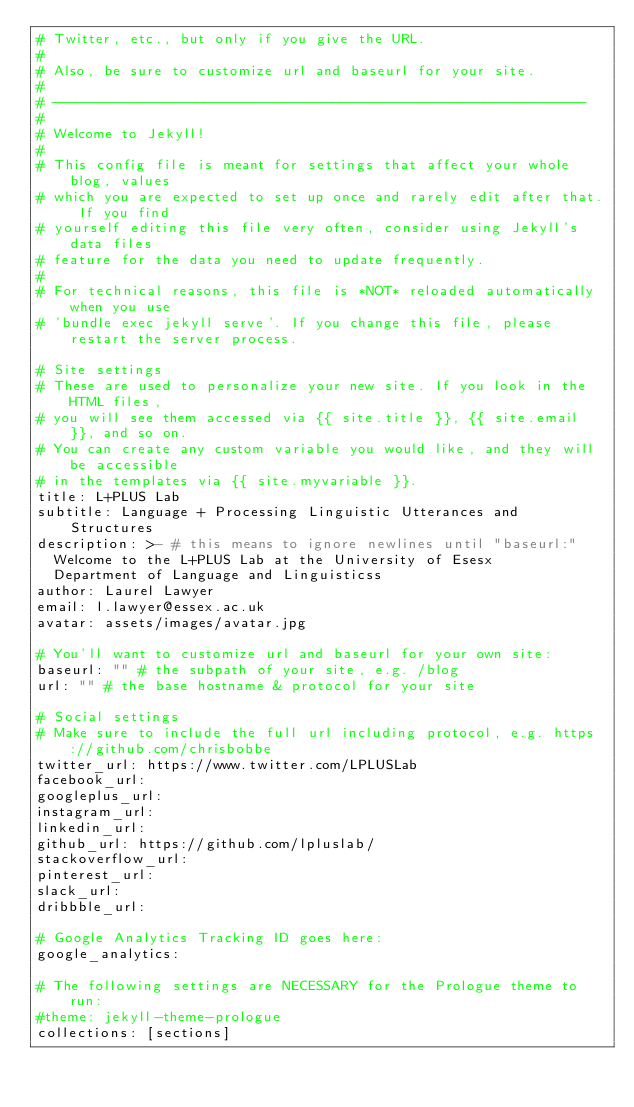Convert code to text. <code><loc_0><loc_0><loc_500><loc_500><_YAML_># Twitter, etc., but only if you give the URL.
#
# Also, be sure to customize url and baseurl for your site.
#
# ---------------------------------------------------------------
#
# Welcome to Jekyll!
#
# This config file is meant for settings that affect your whole blog, values
# which you are expected to set up once and rarely edit after that. If you find
# yourself editing this file very often, consider using Jekyll's data files
# feature for the data you need to update frequently.
#
# For technical reasons, this file is *NOT* reloaded automatically when you use
# 'bundle exec jekyll serve'. If you change this file, please restart the server process.

# Site settings
# These are used to personalize your new site. If you look in the HTML files,
# you will see them accessed via {{ site.title }}, {{ site.email }}, and so on.
# You can create any custom variable you would like, and they will be accessible
# in the templates via {{ site.myvariable }}.
title: L+PLUS Lab
subtitle: Language + Processing Linguistic Utterances and Structures
description: >- # this means to ignore newlines until "baseurl:"
  Welcome to the L+PLUS Lab at the University of Esesx 
  Department of Language and Linguisticss
author: Laurel Lawyer
email: l.lawyer@essex.ac.uk
avatar: assets/images/avatar.jpg

# You'll want to customize url and baseurl for your own site:
baseurl: "" # the subpath of your site, e.g. /blog
url: "" # the base hostname & protocol for your site

# Social settings
# Make sure to include the full url including protocol, e.g. https://github.com/chrisbobbe
twitter_url: https://www.twitter.com/LPLUSLab
facebook_url:
googleplus_url:
instagram_url:
linkedin_url:
github_url: https://github.com/lpluslab/
stackoverflow_url:
pinterest_url:
slack_url:
dribbble_url:

# Google Analytics Tracking ID goes here:
google_analytics:

# The following settings are NECESSARY for the Prologue theme to run:
#theme: jekyll-theme-prologue
collections: [sections]
</code> 